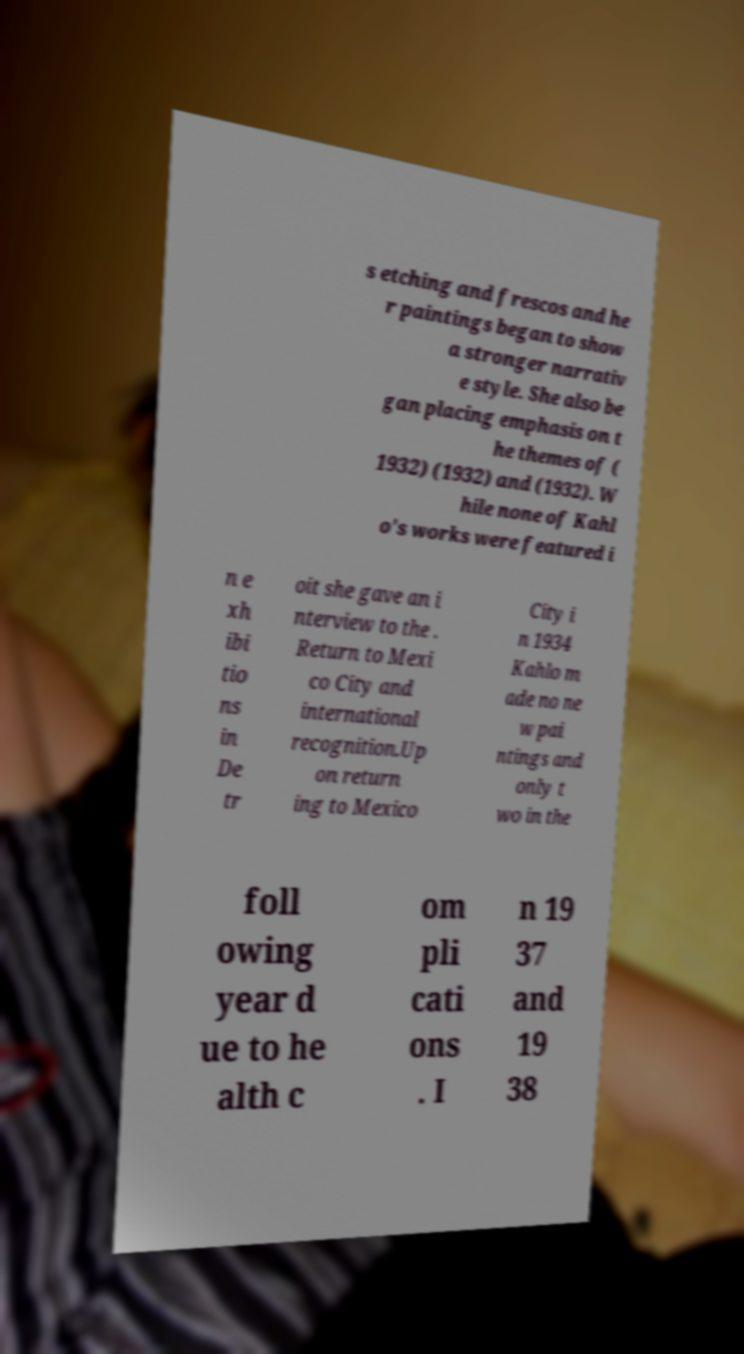Please identify and transcribe the text found in this image. s etching and frescos and he r paintings began to show a stronger narrativ e style. She also be gan placing emphasis on t he themes of ( 1932) (1932) and (1932). W hile none of Kahl o's works were featured i n e xh ibi tio ns in De tr oit she gave an i nterview to the . Return to Mexi co City and international recognition.Up on return ing to Mexico City i n 1934 Kahlo m ade no ne w pai ntings and only t wo in the foll owing year d ue to he alth c om pli cati ons . I n 19 37 and 19 38 